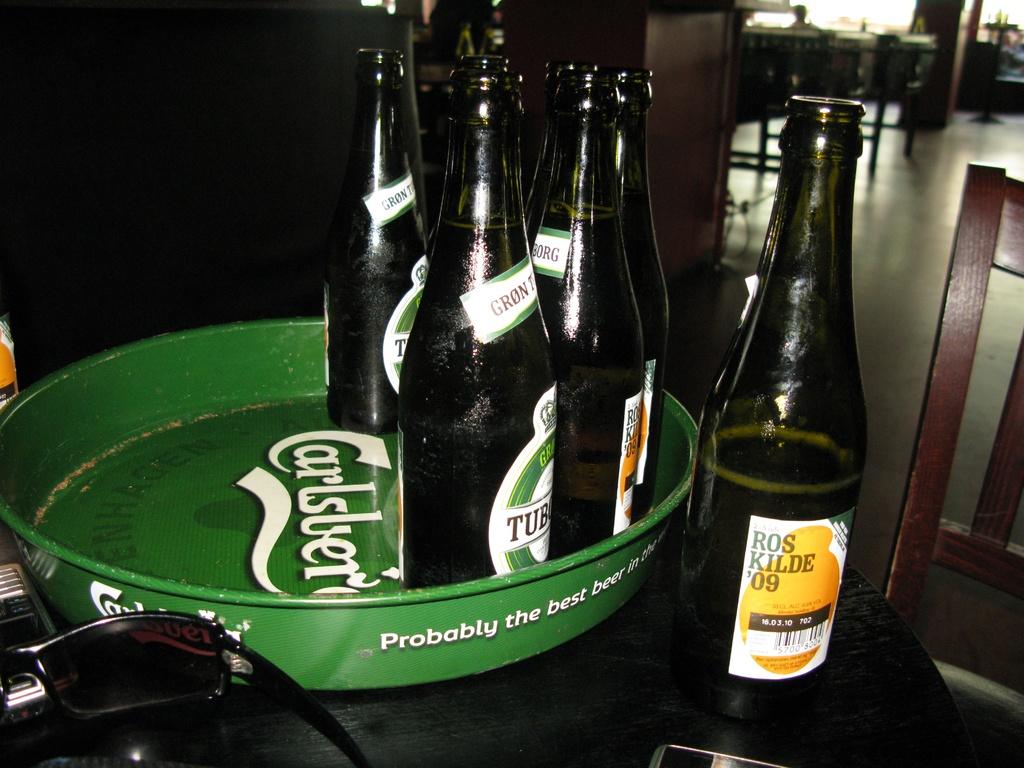What brand is the beer with the yellow label?
Ensure brevity in your answer.  Roskilde '09. What brand does the green tray advertise?
Give a very brief answer. Carlsberg. 